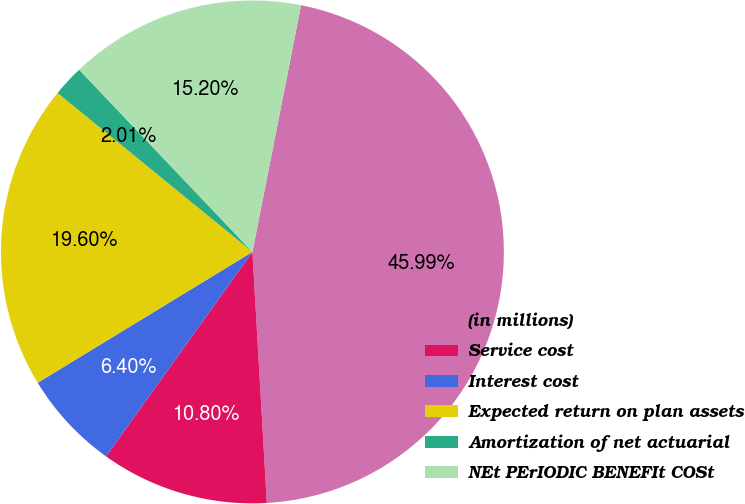Convert chart. <chart><loc_0><loc_0><loc_500><loc_500><pie_chart><fcel>(in millions)<fcel>Service cost<fcel>Interest cost<fcel>Expected return on plan assets<fcel>Amortization of net actuarial<fcel>NEt PErIODIC BENEFIt COSt<nl><fcel>45.99%<fcel>10.8%<fcel>6.4%<fcel>19.6%<fcel>2.01%<fcel>15.2%<nl></chart> 